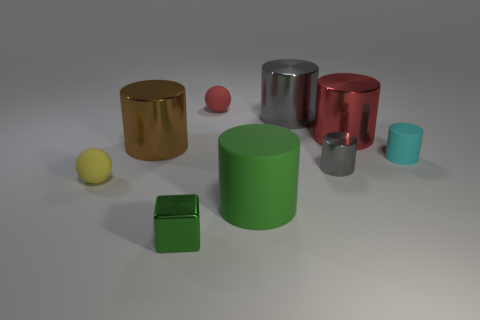There is another large object that is made of the same material as the cyan object; what is its color?
Provide a short and direct response. Green. Is the number of big cylinders greater than the number of big red matte cylinders?
Provide a succinct answer. Yes. Is there a small cyan cylinder?
Your answer should be compact. Yes. There is a small metallic object in front of the matte ball on the left side of the cube; what is its shape?
Provide a succinct answer. Cube. What number of things are either big brown blocks or cylinders on the right side of the red rubber ball?
Offer a terse response. 5. The big shiny cylinder on the right side of the small shiny object right of the tiny green block right of the tiny yellow matte object is what color?
Ensure brevity in your answer.  Red. What is the material of the large brown thing that is the same shape as the big red metal thing?
Make the answer very short. Metal. The tiny matte cylinder has what color?
Your answer should be very brief. Cyan. Does the large matte object have the same color as the small cube?
Give a very brief answer. Yes. What number of rubber objects are green objects or large brown balls?
Your answer should be very brief. 1. 